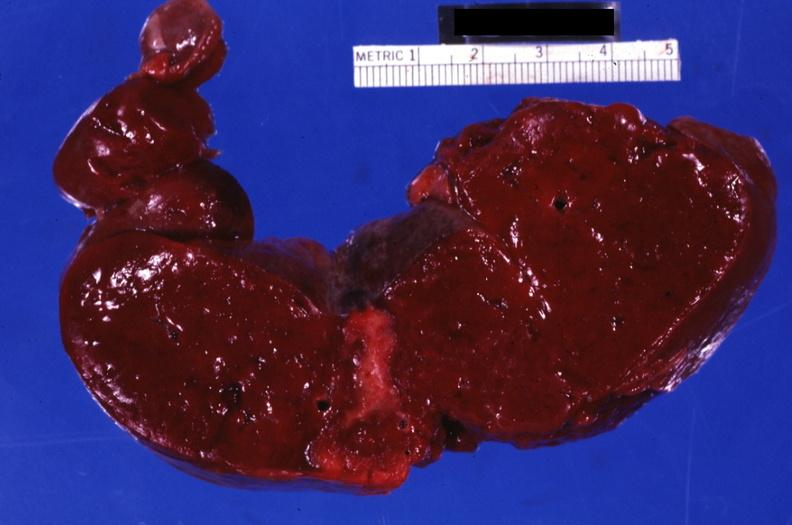s glioma present?
Answer the question using a single word or phrase. No 